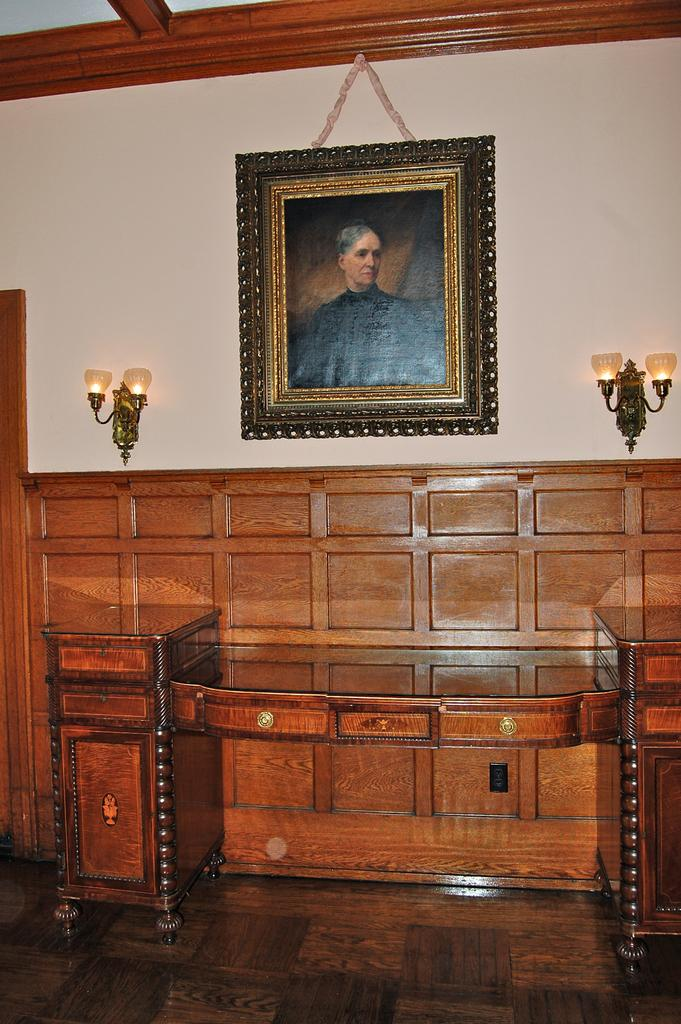What is present on the wall in the image? There is a frame of a person on the wall. What else can be seen on the wall besides the frame? There are lamps on the wall. What is located beside the wall in the image? There is a table beside the wall. What type of bell can be heard ringing in the image? There is no bell present in the image, and therefore no sound can be heard. 